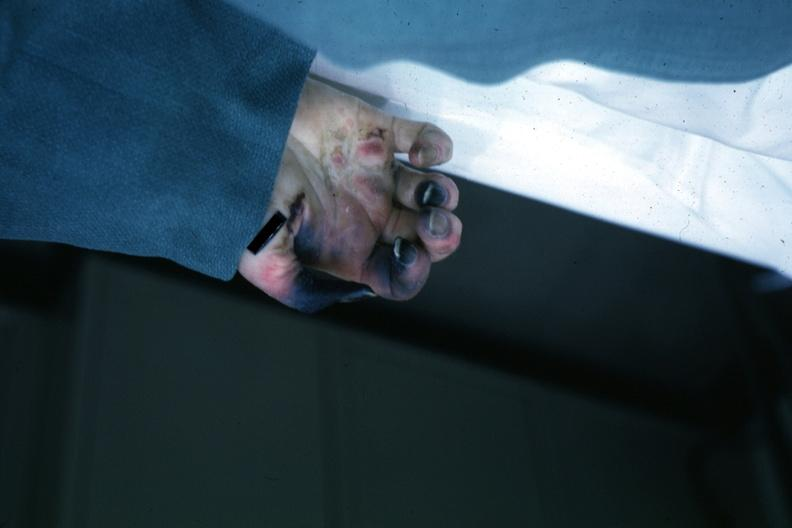s skin over back a buttocks present?
Answer the question using a single word or phrase. No 